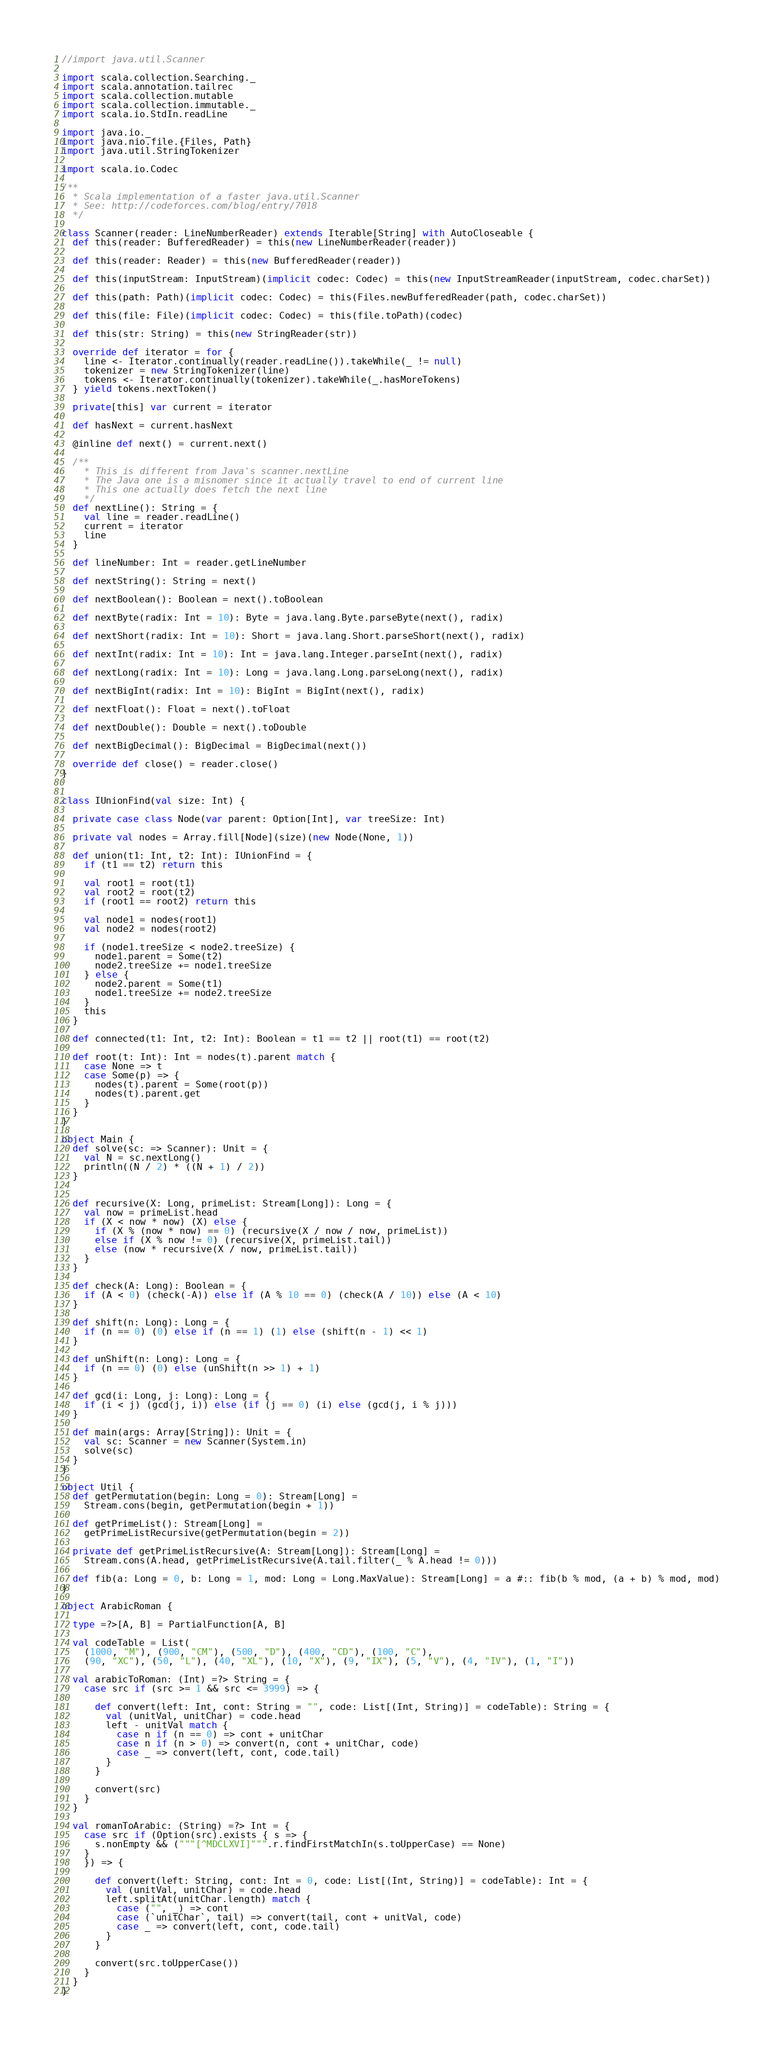<code> <loc_0><loc_0><loc_500><loc_500><_Scala_>//import java.util.Scanner

import scala.collection.Searching._
import scala.annotation.tailrec
import scala.collection.mutable
import scala.collection.immutable._
import scala.io.StdIn.readLine

import java.io._
import java.nio.file.{Files, Path}
import java.util.StringTokenizer

import scala.io.Codec

/**
  * Scala implementation of a faster java.util.Scanner
  * See: http://codeforces.com/blog/entry/7018
  */

class Scanner(reader: LineNumberReader) extends Iterable[String] with AutoCloseable {
  def this(reader: BufferedReader) = this(new LineNumberReader(reader))

  def this(reader: Reader) = this(new BufferedReader(reader))

  def this(inputStream: InputStream)(implicit codec: Codec) = this(new InputStreamReader(inputStream, codec.charSet))

  def this(path: Path)(implicit codec: Codec) = this(Files.newBufferedReader(path, codec.charSet))

  def this(file: File)(implicit codec: Codec) = this(file.toPath)(codec)

  def this(str: String) = this(new StringReader(str))

  override def iterator = for {
    line <- Iterator.continually(reader.readLine()).takeWhile(_ != null)
    tokenizer = new StringTokenizer(line)
    tokens <- Iterator.continually(tokenizer).takeWhile(_.hasMoreTokens)
  } yield tokens.nextToken()

  private[this] var current = iterator

  def hasNext = current.hasNext

  @inline def next() = current.next()

  /**
    * This is different from Java's scanner.nextLine
    * The Java one is a misnomer since it actually travel to end of current line
    * This one actually does fetch the next line
    */
  def nextLine(): String = {
    val line = reader.readLine()
    current = iterator
    line
  }

  def lineNumber: Int = reader.getLineNumber

  def nextString(): String = next()

  def nextBoolean(): Boolean = next().toBoolean

  def nextByte(radix: Int = 10): Byte = java.lang.Byte.parseByte(next(), radix)

  def nextShort(radix: Int = 10): Short = java.lang.Short.parseShort(next(), radix)

  def nextInt(radix: Int = 10): Int = java.lang.Integer.parseInt(next(), radix)

  def nextLong(radix: Int = 10): Long = java.lang.Long.parseLong(next(), radix)

  def nextBigInt(radix: Int = 10): BigInt = BigInt(next(), radix)

  def nextFloat(): Float = next().toFloat

  def nextDouble(): Double = next().toDouble

  def nextBigDecimal(): BigDecimal = BigDecimal(next())

  override def close() = reader.close()
}


class IUnionFind(val size: Int) {

  private case class Node(var parent: Option[Int], var treeSize: Int)

  private val nodes = Array.fill[Node](size)(new Node(None, 1))

  def union(t1: Int, t2: Int): IUnionFind = {
    if (t1 == t2) return this

    val root1 = root(t1)
    val root2 = root(t2)
    if (root1 == root2) return this

    val node1 = nodes(root1)
    val node2 = nodes(root2)

    if (node1.treeSize < node2.treeSize) {
      node1.parent = Some(t2)
      node2.treeSize += node1.treeSize
    } else {
      node2.parent = Some(t1)
      node1.treeSize += node2.treeSize
    }
    this
  }

  def connected(t1: Int, t2: Int): Boolean = t1 == t2 || root(t1) == root(t2)

  def root(t: Int): Int = nodes(t).parent match {
    case None => t
    case Some(p) => {
      nodes(t).parent = Some(root(p))
      nodes(t).parent.get
    }
  }
}

object Main {
  def solve(sc: => Scanner): Unit = {
    val N = sc.nextLong()
    println((N / 2) * ((N + 1) / 2))
  }


  def recursive(X: Long, primeList: Stream[Long]): Long = {
    val now = primeList.head
    if (X < now * now) (X) else {
      if (X % (now * now) == 0) (recursive(X / now / now, primeList))
      else if (X % now != 0) (recursive(X, primeList.tail))
      else (now * recursive(X / now, primeList.tail))
    }
  }

  def check(A: Long): Boolean = {
    if (A < 0) (check(-A)) else if (A % 10 == 0) (check(A / 10)) else (A < 10)
  }

  def shift(n: Long): Long = {
    if (n == 0) (0) else if (n == 1) (1) else (shift(n - 1) << 1)
  }

  def unShift(n: Long): Long = {
    if (n == 0) (0) else (unShift(n >> 1) + 1)
  }

  def gcd(i: Long, j: Long): Long = {
    if (i < j) (gcd(j, i)) else (if (j == 0) (i) else (gcd(j, i % j)))
  }

  def main(args: Array[String]): Unit = {
    val sc: Scanner = new Scanner(System.in)
    solve(sc)
  }
}

object Util {
  def getPermutation(begin: Long = 0): Stream[Long] =
    Stream.cons(begin, getPermutation(begin + 1))

  def getPrimeList(): Stream[Long] =
    getPrimeListRecursive(getPermutation(begin = 2))

  private def getPrimeListRecursive(A: Stream[Long]): Stream[Long] =
    Stream.cons(A.head, getPrimeListRecursive(A.tail.filter(_ % A.head != 0)))

  def fib(a: Long = 0, b: Long = 1, mod: Long = Long.MaxValue): Stream[Long] = a #:: fib(b % mod, (a + b) % mod, mod)
}

object ArabicRoman {

  type =?>[A, B] = PartialFunction[A, B]

  val codeTable = List(
    (1000, "M"), (900, "CM"), (500, "D"), (400, "CD"), (100, "C"),
    (90, "XC"), (50, "L"), (40, "XL"), (10, "X"), (9, "IX"), (5, "V"), (4, "IV"), (1, "I"))

  val arabicToRoman: (Int) =?> String = {
    case src if (src >= 1 && src <= 3999) => {

      def convert(left: Int, cont: String = "", code: List[(Int, String)] = codeTable): String = {
        val (unitVal, unitChar) = code.head
        left - unitVal match {
          case n if (n == 0) => cont + unitChar
          case n if (n > 0) => convert(n, cont + unitChar, code)
          case _ => convert(left, cont, code.tail)
        }
      }

      convert(src)
    }
  }

  val romanToArabic: (String) =?> Int = {
    case src if (Option(src).exists { s => {
      s.nonEmpty && ("""[^MDCLXVI]""".r.findFirstMatchIn(s.toUpperCase) == None)
    }
    }) => {

      def convert(left: String, cont: Int = 0, code: List[(Int, String)] = codeTable): Int = {
        val (unitVal, unitChar) = code.head
        left.splitAt(unitChar.length) match {
          case ("", _) => cont
          case (`unitChar`, tail) => convert(tail, cont + unitVal, code)
          case _ => convert(left, cont, code.tail)
        }
      }

      convert(src.toUpperCase())
    }
  }
}
</code> 